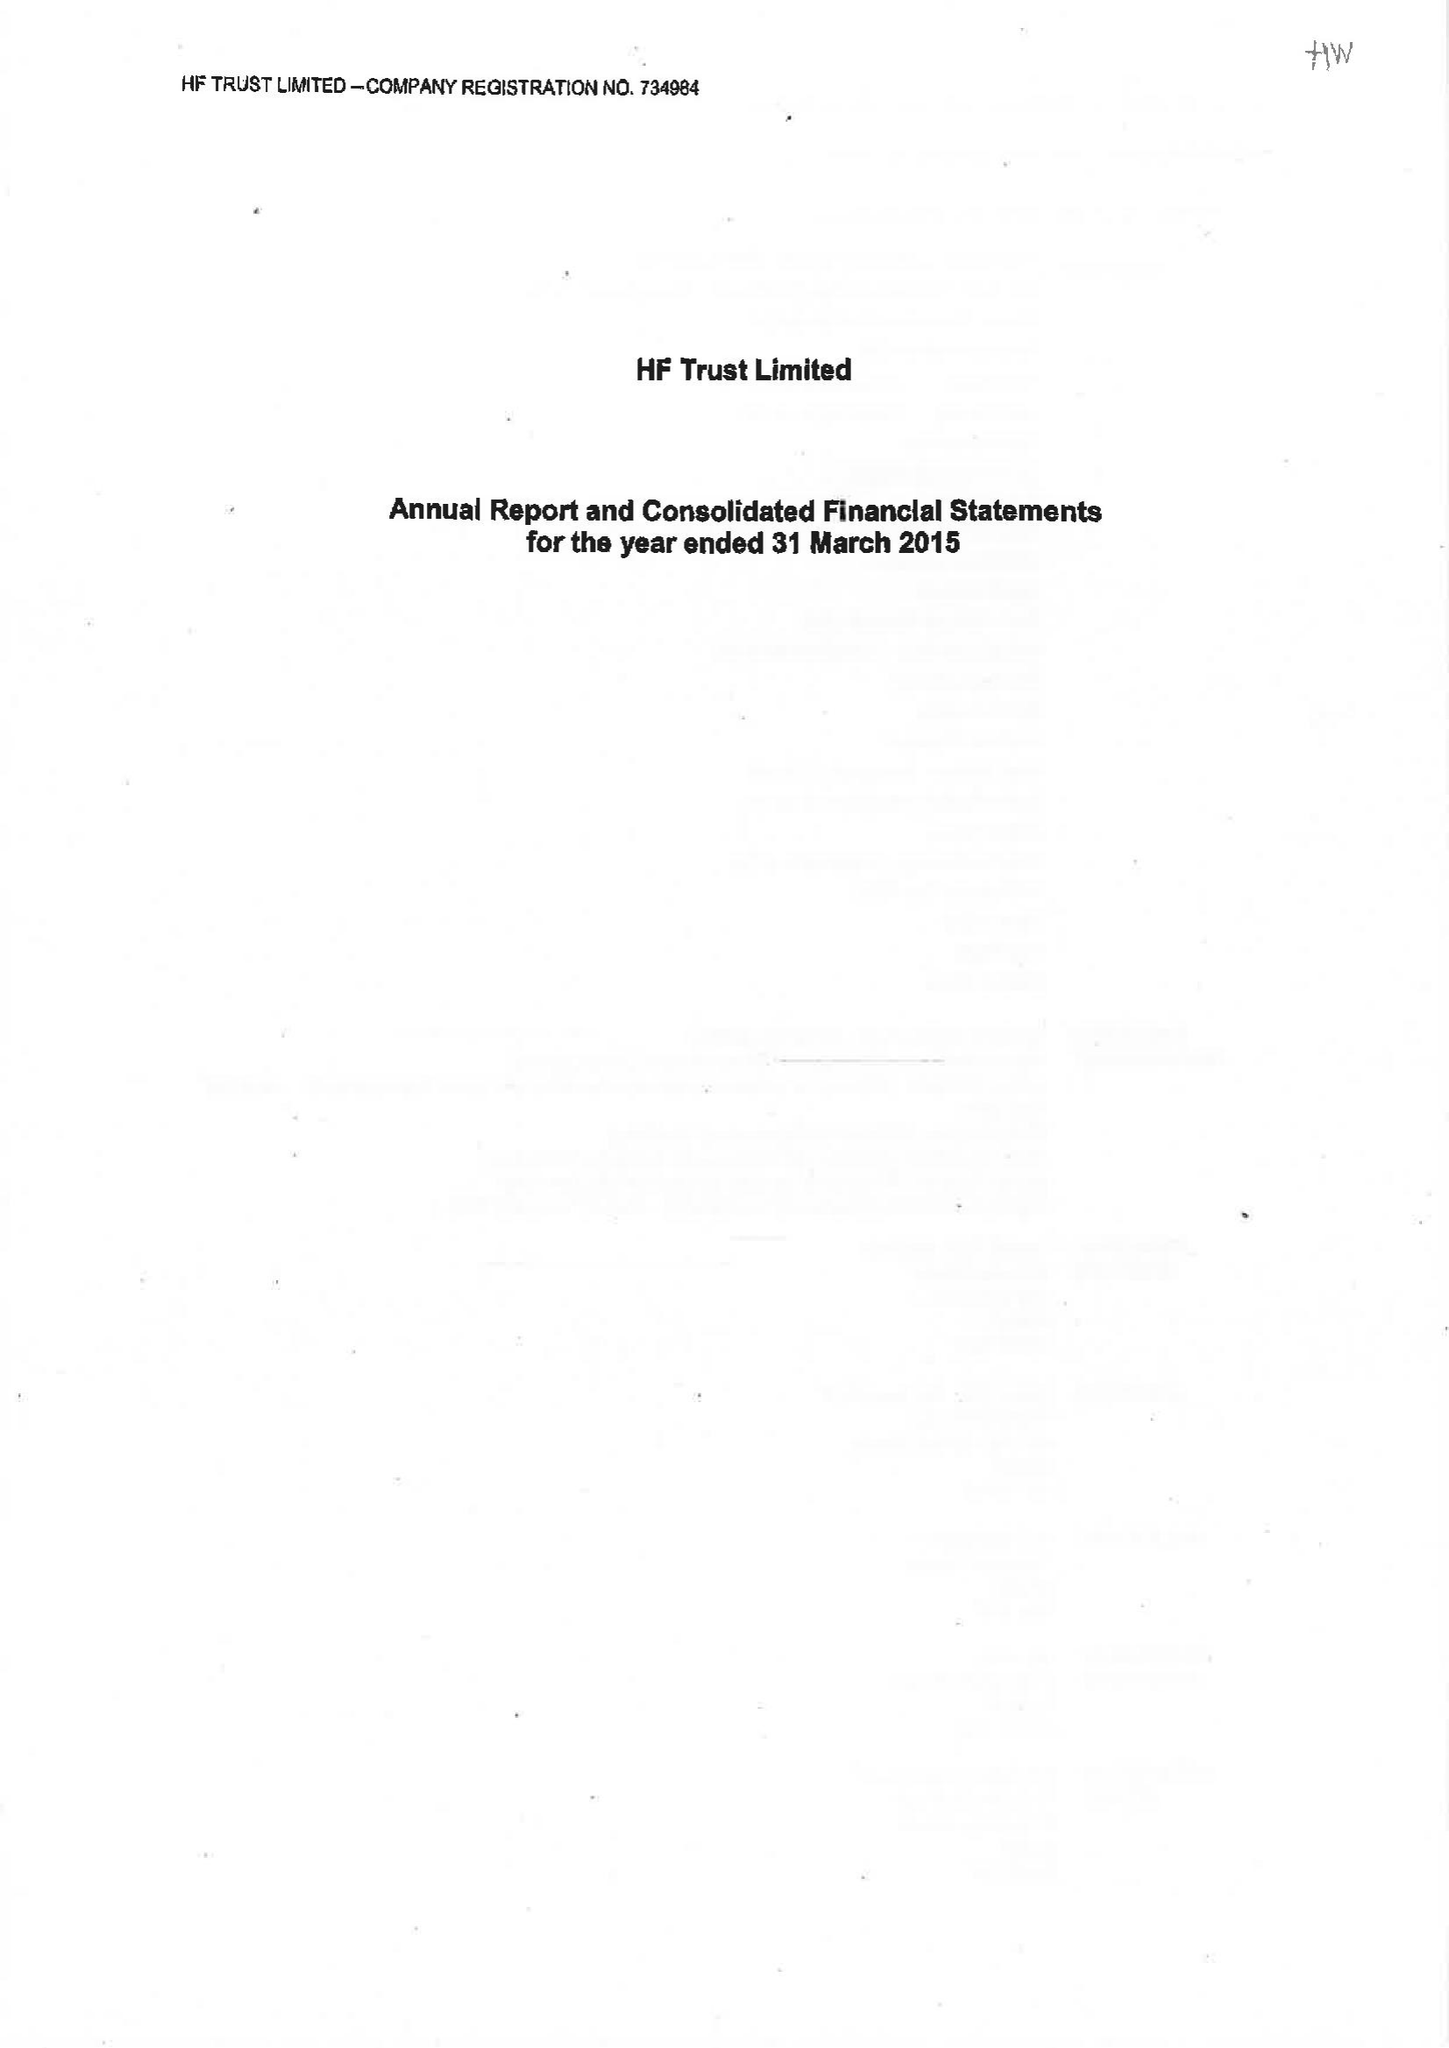What is the value for the spending_annually_in_british_pounds?
Answer the question using a single word or phrase. 74910000.00 